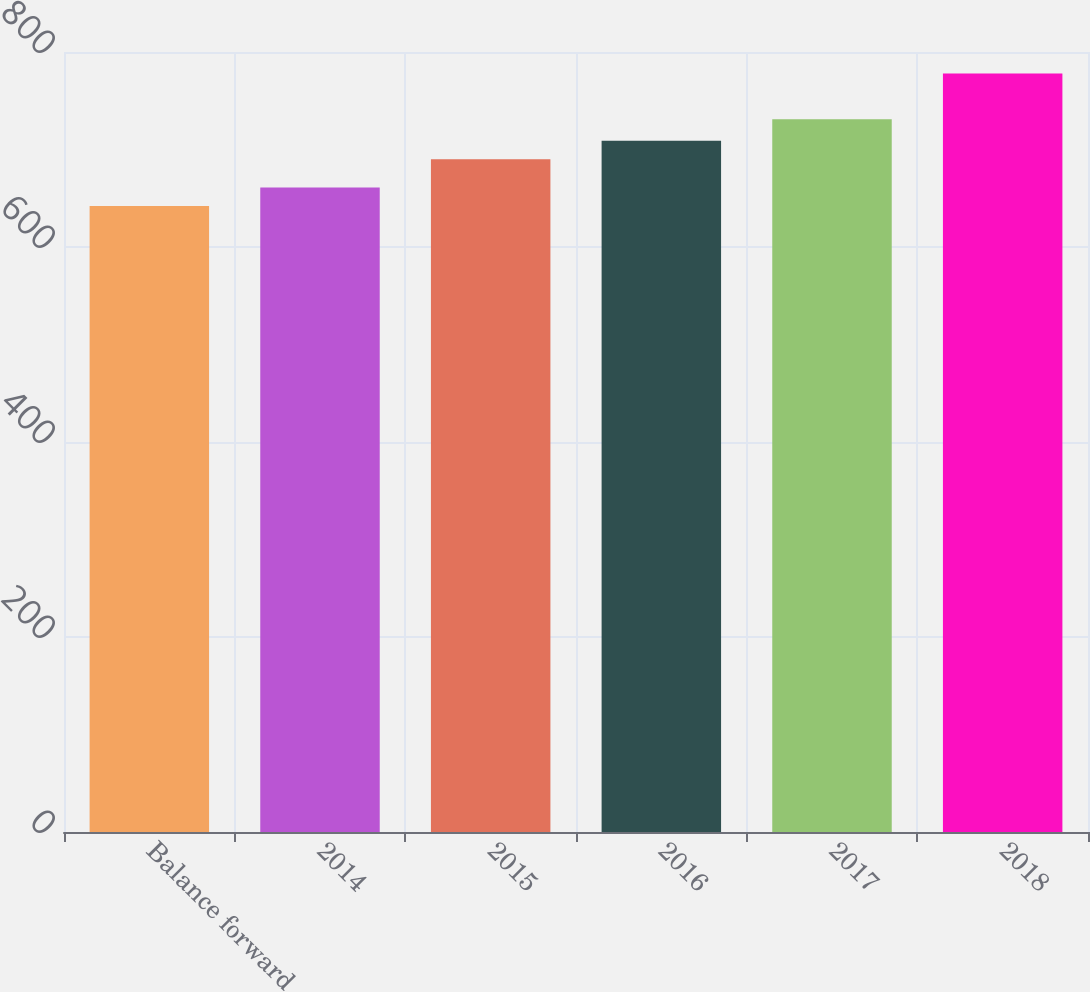Convert chart to OTSL. <chart><loc_0><loc_0><loc_500><loc_500><bar_chart><fcel>Balance forward<fcel>2014<fcel>2015<fcel>2016<fcel>2017<fcel>2018<nl><fcel>642<fcel>661<fcel>690<fcel>709<fcel>731<fcel>778<nl></chart> 